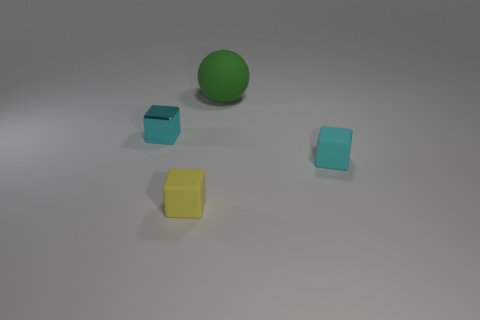How are the objects arranged in relation to each other? The objects are placed sporadically with enough space between them. No object overlaps another, and they are positioned at varying distances from the perspective of the viewer, giving a sense of three-dimensionality to the arrangement. 